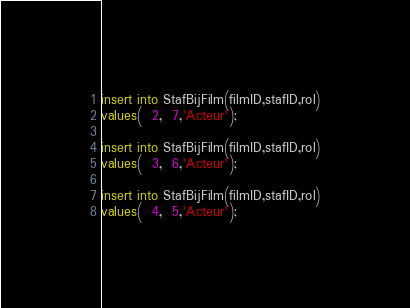Convert code to text. <code><loc_0><loc_0><loc_500><loc_500><_SQL_>insert into StafBijFilm(filmID,stafID,rol)
values(  2,  7,'Acteur');

insert into StafBijFilm(filmID,stafID,rol)
values(  3,  6,'Acteur');

insert into StafBijFilm(filmID,stafID,rol)
values(  4,  5,'Acteur');
</code> 